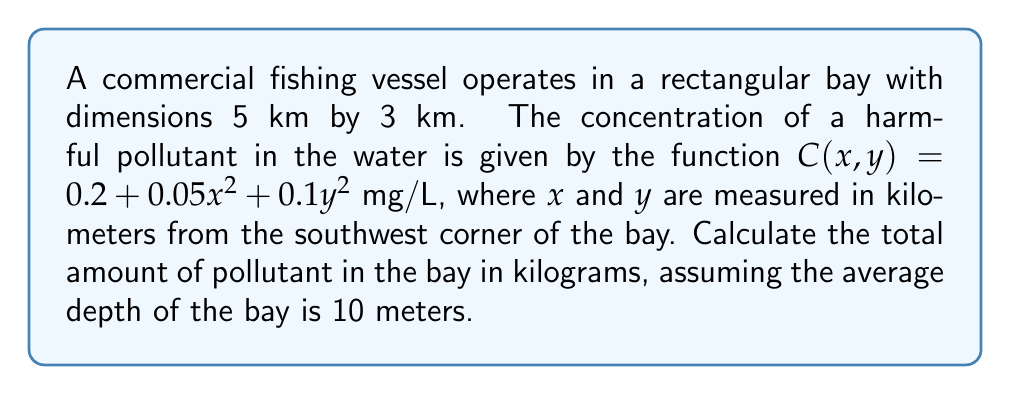Help me with this question. To solve this problem, we need to use a double integral to calculate the total amount of pollutant in the bay. Let's break it down step by step:

1) The concentration function is given as $C(x,y) = 0.2 + 0.05x^2 + 0.1y^2$ mg/L.

2) The bay dimensions are 5 km by 3 km, so our limits of integration will be:
   $0 \leq x \leq 5$ and $0 \leq y \leq 3$

3) To find the total amount of pollutant, we need to integrate the concentration function over the area of the bay and multiply by the depth:

   $\text{Total pollutant} = \text{depth} \cdot \int_0^3 \int_0^5 C(x,y) \, dx \, dy$

4) Substituting the concentration function and converting units:
   
   $\text{Total pollutant} = 10 \text{ m} \cdot \int_0^3 \int_0^5 (0.2 + 0.05x^2 + 0.1y^2) \, dx \, dy \cdot \frac{1000 \text{ L}}{1 \text{ m}^3} \cdot \frac{1 \text{ kg}}{1000000 \text{ mg}}$

5) Simplifying the conversion factor:

   $\text{Total pollutant} = 0.01 \cdot \int_0^3 \int_0^5 (0.2 + 0.05x^2 + 0.1y^2) \, dx \, dy \text{ kg}$

6) Evaluating the inner integral:

   $\int_0^3 \left[0.2x + \frac{0.05x^3}{3} + 0.1xy^2\right]_0^5 \, dy$

   $= \int_0^3 (1 + \frac{6.25}{3} + 0.5y^2) \, dy$

7) Evaluating the outer integral:

   $\left[y + \frac{6.25y}{3} + \frac{0.5y^3}{3}\right]_0^3$

   $= (3 + 6.25 + 4.5) - (0 + 0 + 0) = 13.75$

8) Multiplying by the conversion factor:

   $\text{Total pollutant} = 0.01 \cdot 13.75 = 0.1375 \text{ kg}$
Answer: The total amount of pollutant in the bay is 0.1375 kg. 